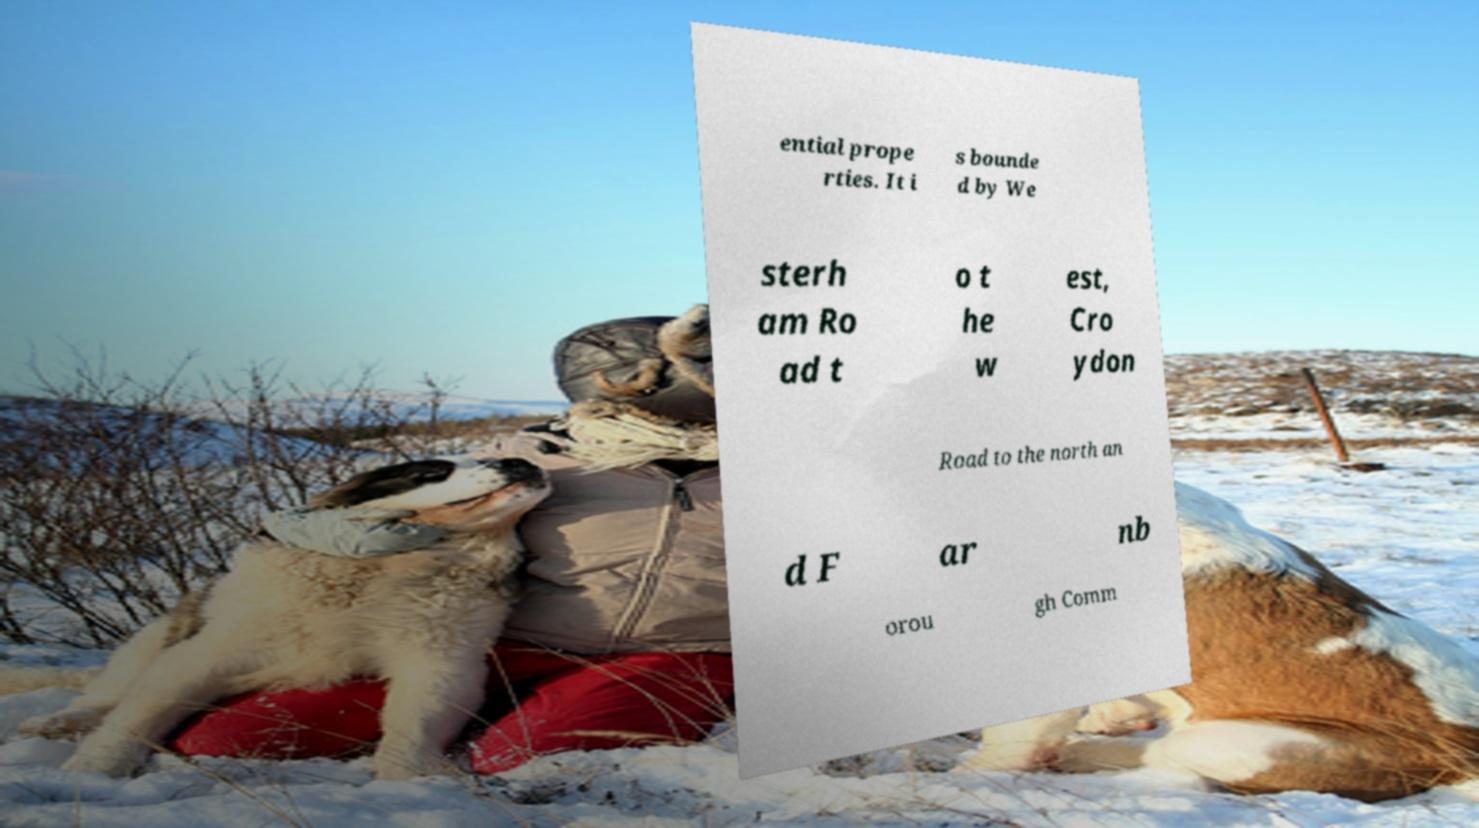Please read and relay the text visible in this image. What does it say? ential prope rties. It i s bounde d by We sterh am Ro ad t o t he w est, Cro ydon Road to the north an d F ar nb orou gh Comm 